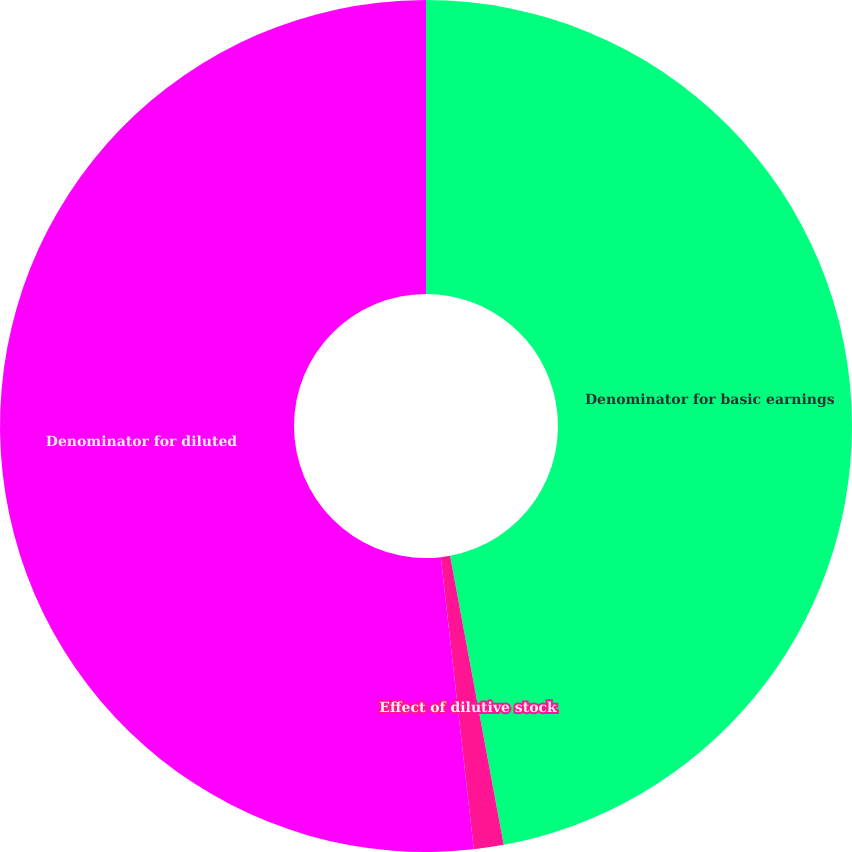Convert chart to OTSL. <chart><loc_0><loc_0><loc_500><loc_500><pie_chart><fcel>Denominator for basic earnings<fcel>Effect of dilutive stock<fcel>Denominator for diluted<nl><fcel>47.08%<fcel>1.13%<fcel>51.79%<nl></chart> 